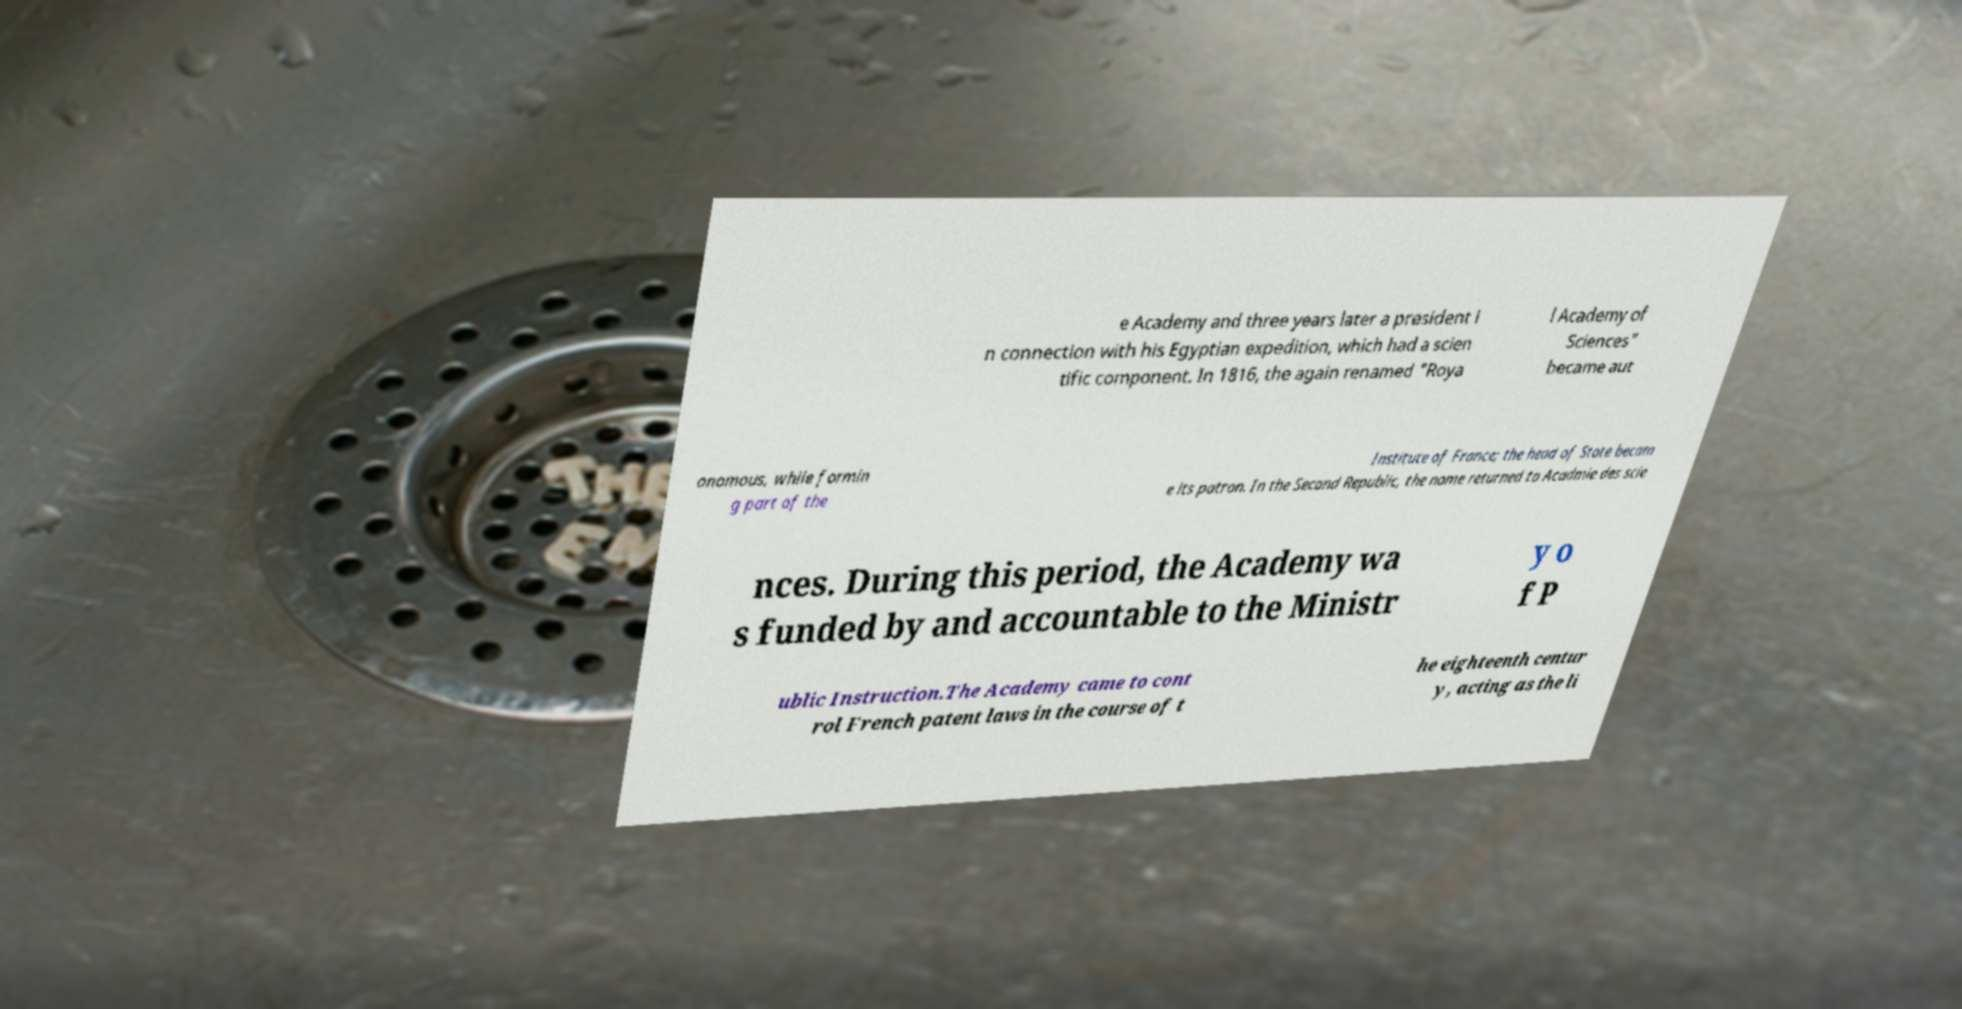Could you extract and type out the text from this image? e Academy and three years later a president i n connection with his Egyptian expedition, which had a scien tific component. In 1816, the again renamed "Roya l Academy of Sciences" became aut onomous, while formin g part of the Institute of France; the head of State becam e its patron. In the Second Republic, the name returned to Acadmie des scie nces. During this period, the Academy wa s funded by and accountable to the Ministr y o f P ublic Instruction.The Academy came to cont rol French patent laws in the course of t he eighteenth centur y, acting as the li 